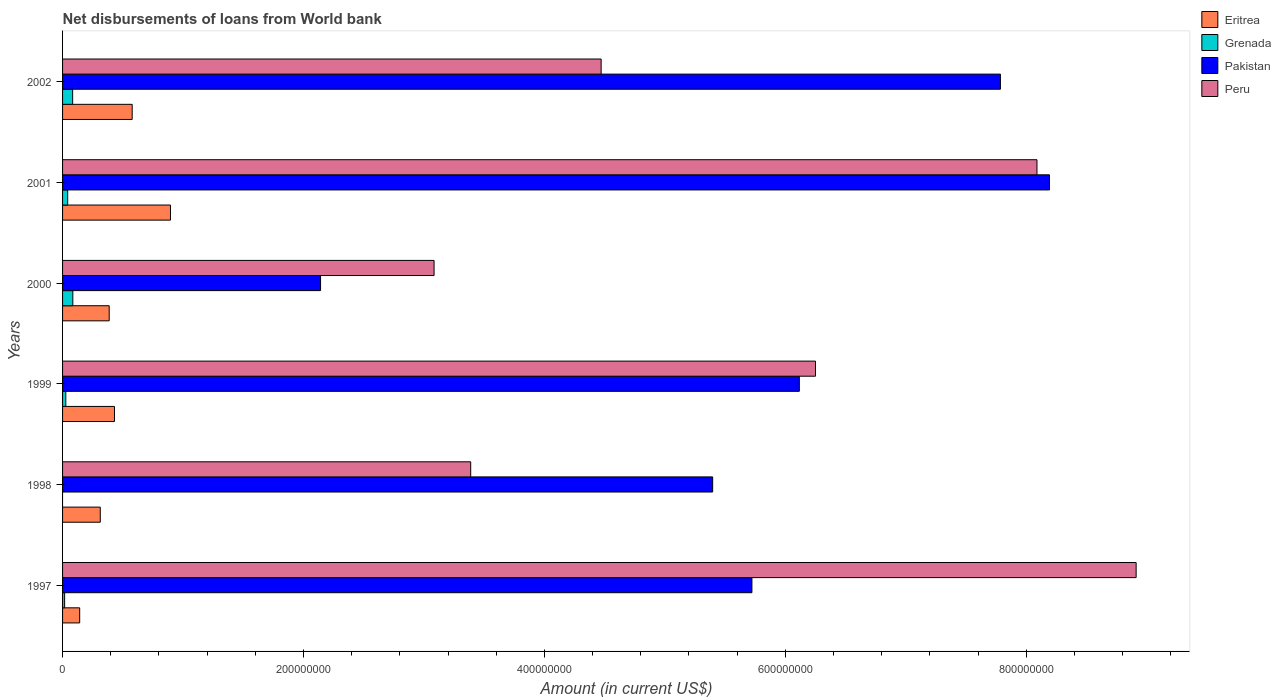How many different coloured bars are there?
Ensure brevity in your answer.  4. How many groups of bars are there?
Ensure brevity in your answer.  6. How many bars are there on the 3rd tick from the top?
Provide a short and direct response. 4. What is the amount of loan disbursed from World Bank in Grenada in 2002?
Your answer should be compact. 8.38e+06. Across all years, what is the maximum amount of loan disbursed from World Bank in Peru?
Provide a short and direct response. 8.91e+08. Across all years, what is the minimum amount of loan disbursed from World Bank in Pakistan?
Ensure brevity in your answer.  2.14e+08. In which year was the amount of loan disbursed from World Bank in Pakistan maximum?
Offer a very short reply. 2001. What is the total amount of loan disbursed from World Bank in Pakistan in the graph?
Your response must be concise. 3.54e+09. What is the difference between the amount of loan disbursed from World Bank in Grenada in 1997 and that in 1999?
Offer a terse response. -9.86e+05. What is the difference between the amount of loan disbursed from World Bank in Pakistan in 1998 and the amount of loan disbursed from World Bank in Grenada in 1997?
Provide a short and direct response. 5.38e+08. What is the average amount of loan disbursed from World Bank in Eritrea per year?
Your answer should be compact. 4.58e+07. In the year 1997, what is the difference between the amount of loan disbursed from World Bank in Pakistan and amount of loan disbursed from World Bank in Eritrea?
Keep it short and to the point. 5.58e+08. What is the ratio of the amount of loan disbursed from World Bank in Eritrea in 2000 to that in 2001?
Offer a very short reply. 0.43. Is the difference between the amount of loan disbursed from World Bank in Pakistan in 2000 and 2001 greater than the difference between the amount of loan disbursed from World Bank in Eritrea in 2000 and 2001?
Offer a terse response. No. What is the difference between the highest and the second highest amount of loan disbursed from World Bank in Peru?
Give a very brief answer. 8.23e+07. What is the difference between the highest and the lowest amount of loan disbursed from World Bank in Peru?
Your answer should be very brief. 5.83e+08. In how many years, is the amount of loan disbursed from World Bank in Grenada greater than the average amount of loan disbursed from World Bank in Grenada taken over all years?
Offer a terse response. 2. Is it the case that in every year, the sum of the amount of loan disbursed from World Bank in Peru and amount of loan disbursed from World Bank in Pakistan is greater than the sum of amount of loan disbursed from World Bank in Grenada and amount of loan disbursed from World Bank in Eritrea?
Keep it short and to the point. Yes. How many bars are there?
Ensure brevity in your answer.  23. How many years are there in the graph?
Ensure brevity in your answer.  6. Does the graph contain any zero values?
Your answer should be very brief. Yes. Does the graph contain grids?
Make the answer very short. No. Where does the legend appear in the graph?
Your answer should be very brief. Top right. How are the legend labels stacked?
Keep it short and to the point. Vertical. What is the title of the graph?
Ensure brevity in your answer.  Net disbursements of loans from World bank. What is the label or title of the X-axis?
Provide a short and direct response. Amount (in current US$). What is the label or title of the Y-axis?
Keep it short and to the point. Years. What is the Amount (in current US$) of Eritrea in 1997?
Ensure brevity in your answer.  1.42e+07. What is the Amount (in current US$) of Grenada in 1997?
Your answer should be very brief. 1.72e+06. What is the Amount (in current US$) of Pakistan in 1997?
Your response must be concise. 5.72e+08. What is the Amount (in current US$) of Peru in 1997?
Your answer should be compact. 8.91e+08. What is the Amount (in current US$) of Eritrea in 1998?
Ensure brevity in your answer.  3.13e+07. What is the Amount (in current US$) in Pakistan in 1998?
Provide a succinct answer. 5.40e+08. What is the Amount (in current US$) of Peru in 1998?
Keep it short and to the point. 3.39e+08. What is the Amount (in current US$) of Eritrea in 1999?
Make the answer very short. 4.31e+07. What is the Amount (in current US$) of Grenada in 1999?
Provide a short and direct response. 2.70e+06. What is the Amount (in current US$) in Pakistan in 1999?
Ensure brevity in your answer.  6.12e+08. What is the Amount (in current US$) in Peru in 1999?
Offer a very short reply. 6.25e+08. What is the Amount (in current US$) of Eritrea in 2000?
Your answer should be compact. 3.87e+07. What is the Amount (in current US$) of Grenada in 2000?
Offer a terse response. 8.52e+06. What is the Amount (in current US$) in Pakistan in 2000?
Offer a terse response. 2.14e+08. What is the Amount (in current US$) of Peru in 2000?
Provide a succinct answer. 3.08e+08. What is the Amount (in current US$) in Eritrea in 2001?
Your response must be concise. 8.96e+07. What is the Amount (in current US$) of Grenada in 2001?
Ensure brevity in your answer.  4.25e+06. What is the Amount (in current US$) in Pakistan in 2001?
Your answer should be compact. 8.19e+08. What is the Amount (in current US$) in Peru in 2001?
Your answer should be very brief. 8.09e+08. What is the Amount (in current US$) of Eritrea in 2002?
Your answer should be compact. 5.78e+07. What is the Amount (in current US$) in Grenada in 2002?
Your response must be concise. 8.38e+06. What is the Amount (in current US$) in Pakistan in 2002?
Give a very brief answer. 7.79e+08. What is the Amount (in current US$) in Peru in 2002?
Your answer should be compact. 4.47e+08. Across all years, what is the maximum Amount (in current US$) of Eritrea?
Your response must be concise. 8.96e+07. Across all years, what is the maximum Amount (in current US$) in Grenada?
Ensure brevity in your answer.  8.52e+06. Across all years, what is the maximum Amount (in current US$) in Pakistan?
Your answer should be very brief. 8.19e+08. Across all years, what is the maximum Amount (in current US$) of Peru?
Your answer should be very brief. 8.91e+08. Across all years, what is the minimum Amount (in current US$) of Eritrea?
Offer a terse response. 1.42e+07. Across all years, what is the minimum Amount (in current US$) of Grenada?
Your response must be concise. 0. Across all years, what is the minimum Amount (in current US$) in Pakistan?
Offer a very short reply. 2.14e+08. Across all years, what is the minimum Amount (in current US$) in Peru?
Offer a very short reply. 3.08e+08. What is the total Amount (in current US$) in Eritrea in the graph?
Your answer should be compact. 2.75e+08. What is the total Amount (in current US$) in Grenada in the graph?
Keep it short and to the point. 2.56e+07. What is the total Amount (in current US$) in Pakistan in the graph?
Offer a terse response. 3.54e+09. What is the total Amount (in current US$) in Peru in the graph?
Offer a very short reply. 3.42e+09. What is the difference between the Amount (in current US$) in Eritrea in 1997 and that in 1998?
Offer a terse response. -1.71e+07. What is the difference between the Amount (in current US$) of Pakistan in 1997 and that in 1998?
Your response must be concise. 3.26e+07. What is the difference between the Amount (in current US$) of Peru in 1997 and that in 1998?
Make the answer very short. 5.52e+08. What is the difference between the Amount (in current US$) in Eritrea in 1997 and that in 1999?
Your response must be concise. -2.89e+07. What is the difference between the Amount (in current US$) of Grenada in 1997 and that in 1999?
Offer a terse response. -9.86e+05. What is the difference between the Amount (in current US$) of Pakistan in 1997 and that in 1999?
Keep it short and to the point. -3.94e+07. What is the difference between the Amount (in current US$) of Peru in 1997 and that in 1999?
Give a very brief answer. 2.66e+08. What is the difference between the Amount (in current US$) of Eritrea in 1997 and that in 2000?
Give a very brief answer. -2.45e+07. What is the difference between the Amount (in current US$) of Grenada in 1997 and that in 2000?
Your answer should be compact. -6.80e+06. What is the difference between the Amount (in current US$) of Pakistan in 1997 and that in 2000?
Offer a terse response. 3.58e+08. What is the difference between the Amount (in current US$) of Peru in 1997 and that in 2000?
Keep it short and to the point. 5.83e+08. What is the difference between the Amount (in current US$) of Eritrea in 1997 and that in 2001?
Offer a very short reply. -7.54e+07. What is the difference between the Amount (in current US$) of Grenada in 1997 and that in 2001?
Provide a succinct answer. -2.54e+06. What is the difference between the Amount (in current US$) in Pakistan in 1997 and that in 2001?
Provide a succinct answer. -2.47e+08. What is the difference between the Amount (in current US$) of Peru in 1997 and that in 2001?
Offer a terse response. 8.23e+07. What is the difference between the Amount (in current US$) of Eritrea in 1997 and that in 2002?
Provide a succinct answer. -4.36e+07. What is the difference between the Amount (in current US$) of Grenada in 1997 and that in 2002?
Offer a very short reply. -6.66e+06. What is the difference between the Amount (in current US$) of Pakistan in 1997 and that in 2002?
Give a very brief answer. -2.06e+08. What is the difference between the Amount (in current US$) of Peru in 1997 and that in 2002?
Provide a short and direct response. 4.44e+08. What is the difference between the Amount (in current US$) of Eritrea in 1998 and that in 1999?
Provide a succinct answer. -1.18e+07. What is the difference between the Amount (in current US$) in Pakistan in 1998 and that in 1999?
Your answer should be compact. -7.19e+07. What is the difference between the Amount (in current US$) of Peru in 1998 and that in 1999?
Your answer should be compact. -2.86e+08. What is the difference between the Amount (in current US$) in Eritrea in 1998 and that in 2000?
Your answer should be very brief. -7.42e+06. What is the difference between the Amount (in current US$) of Pakistan in 1998 and that in 2000?
Make the answer very short. 3.26e+08. What is the difference between the Amount (in current US$) in Peru in 1998 and that in 2000?
Provide a short and direct response. 3.04e+07. What is the difference between the Amount (in current US$) in Eritrea in 1998 and that in 2001?
Your answer should be very brief. -5.83e+07. What is the difference between the Amount (in current US$) in Pakistan in 1998 and that in 2001?
Make the answer very short. -2.80e+08. What is the difference between the Amount (in current US$) in Peru in 1998 and that in 2001?
Provide a succinct answer. -4.70e+08. What is the difference between the Amount (in current US$) in Eritrea in 1998 and that in 2002?
Provide a succinct answer. -2.65e+07. What is the difference between the Amount (in current US$) in Pakistan in 1998 and that in 2002?
Make the answer very short. -2.39e+08. What is the difference between the Amount (in current US$) of Peru in 1998 and that in 2002?
Your response must be concise. -1.08e+08. What is the difference between the Amount (in current US$) of Eritrea in 1999 and that in 2000?
Provide a succinct answer. 4.38e+06. What is the difference between the Amount (in current US$) in Grenada in 1999 and that in 2000?
Give a very brief answer. -5.82e+06. What is the difference between the Amount (in current US$) in Pakistan in 1999 and that in 2000?
Keep it short and to the point. 3.97e+08. What is the difference between the Amount (in current US$) in Peru in 1999 and that in 2000?
Give a very brief answer. 3.17e+08. What is the difference between the Amount (in current US$) of Eritrea in 1999 and that in 2001?
Your answer should be very brief. -4.65e+07. What is the difference between the Amount (in current US$) in Grenada in 1999 and that in 2001?
Ensure brevity in your answer.  -1.55e+06. What is the difference between the Amount (in current US$) of Pakistan in 1999 and that in 2001?
Offer a terse response. -2.08e+08. What is the difference between the Amount (in current US$) of Peru in 1999 and that in 2001?
Offer a terse response. -1.84e+08. What is the difference between the Amount (in current US$) of Eritrea in 1999 and that in 2002?
Offer a terse response. -1.47e+07. What is the difference between the Amount (in current US$) in Grenada in 1999 and that in 2002?
Your answer should be very brief. -5.67e+06. What is the difference between the Amount (in current US$) in Pakistan in 1999 and that in 2002?
Make the answer very short. -1.67e+08. What is the difference between the Amount (in current US$) of Peru in 1999 and that in 2002?
Provide a short and direct response. 1.78e+08. What is the difference between the Amount (in current US$) in Eritrea in 2000 and that in 2001?
Provide a short and direct response. -5.09e+07. What is the difference between the Amount (in current US$) in Grenada in 2000 and that in 2001?
Ensure brevity in your answer.  4.27e+06. What is the difference between the Amount (in current US$) in Pakistan in 2000 and that in 2001?
Give a very brief answer. -6.05e+08. What is the difference between the Amount (in current US$) in Peru in 2000 and that in 2001?
Your response must be concise. -5.00e+08. What is the difference between the Amount (in current US$) in Eritrea in 2000 and that in 2002?
Provide a short and direct response. -1.91e+07. What is the difference between the Amount (in current US$) of Grenada in 2000 and that in 2002?
Provide a succinct answer. 1.44e+05. What is the difference between the Amount (in current US$) of Pakistan in 2000 and that in 2002?
Keep it short and to the point. -5.64e+08. What is the difference between the Amount (in current US$) of Peru in 2000 and that in 2002?
Make the answer very short. -1.39e+08. What is the difference between the Amount (in current US$) of Eritrea in 2001 and that in 2002?
Provide a short and direct response. 3.18e+07. What is the difference between the Amount (in current US$) of Grenada in 2001 and that in 2002?
Ensure brevity in your answer.  -4.12e+06. What is the difference between the Amount (in current US$) in Pakistan in 2001 and that in 2002?
Your response must be concise. 4.07e+07. What is the difference between the Amount (in current US$) of Peru in 2001 and that in 2002?
Your answer should be very brief. 3.62e+08. What is the difference between the Amount (in current US$) in Eritrea in 1997 and the Amount (in current US$) in Pakistan in 1998?
Your response must be concise. -5.25e+08. What is the difference between the Amount (in current US$) in Eritrea in 1997 and the Amount (in current US$) in Peru in 1998?
Keep it short and to the point. -3.25e+08. What is the difference between the Amount (in current US$) of Grenada in 1997 and the Amount (in current US$) of Pakistan in 1998?
Ensure brevity in your answer.  -5.38e+08. What is the difference between the Amount (in current US$) in Grenada in 1997 and the Amount (in current US$) in Peru in 1998?
Provide a short and direct response. -3.37e+08. What is the difference between the Amount (in current US$) of Pakistan in 1997 and the Amount (in current US$) of Peru in 1998?
Your response must be concise. 2.33e+08. What is the difference between the Amount (in current US$) of Eritrea in 1997 and the Amount (in current US$) of Grenada in 1999?
Offer a very short reply. 1.15e+07. What is the difference between the Amount (in current US$) in Eritrea in 1997 and the Amount (in current US$) in Pakistan in 1999?
Offer a very short reply. -5.97e+08. What is the difference between the Amount (in current US$) of Eritrea in 1997 and the Amount (in current US$) of Peru in 1999?
Ensure brevity in your answer.  -6.11e+08. What is the difference between the Amount (in current US$) in Grenada in 1997 and the Amount (in current US$) in Pakistan in 1999?
Your response must be concise. -6.10e+08. What is the difference between the Amount (in current US$) of Grenada in 1997 and the Amount (in current US$) of Peru in 1999?
Your answer should be very brief. -6.23e+08. What is the difference between the Amount (in current US$) in Pakistan in 1997 and the Amount (in current US$) in Peru in 1999?
Offer a terse response. -5.28e+07. What is the difference between the Amount (in current US$) in Eritrea in 1997 and the Amount (in current US$) in Grenada in 2000?
Keep it short and to the point. 5.69e+06. What is the difference between the Amount (in current US$) in Eritrea in 1997 and the Amount (in current US$) in Pakistan in 2000?
Your answer should be very brief. -2.00e+08. What is the difference between the Amount (in current US$) of Eritrea in 1997 and the Amount (in current US$) of Peru in 2000?
Give a very brief answer. -2.94e+08. What is the difference between the Amount (in current US$) in Grenada in 1997 and the Amount (in current US$) in Pakistan in 2000?
Ensure brevity in your answer.  -2.12e+08. What is the difference between the Amount (in current US$) of Grenada in 1997 and the Amount (in current US$) of Peru in 2000?
Offer a very short reply. -3.07e+08. What is the difference between the Amount (in current US$) of Pakistan in 1997 and the Amount (in current US$) of Peru in 2000?
Your response must be concise. 2.64e+08. What is the difference between the Amount (in current US$) of Eritrea in 1997 and the Amount (in current US$) of Grenada in 2001?
Your response must be concise. 9.96e+06. What is the difference between the Amount (in current US$) of Eritrea in 1997 and the Amount (in current US$) of Pakistan in 2001?
Your response must be concise. -8.05e+08. What is the difference between the Amount (in current US$) of Eritrea in 1997 and the Amount (in current US$) of Peru in 2001?
Your response must be concise. -7.95e+08. What is the difference between the Amount (in current US$) in Grenada in 1997 and the Amount (in current US$) in Pakistan in 2001?
Your response must be concise. -8.18e+08. What is the difference between the Amount (in current US$) of Grenada in 1997 and the Amount (in current US$) of Peru in 2001?
Offer a very short reply. -8.07e+08. What is the difference between the Amount (in current US$) of Pakistan in 1997 and the Amount (in current US$) of Peru in 2001?
Offer a terse response. -2.37e+08. What is the difference between the Amount (in current US$) in Eritrea in 1997 and the Amount (in current US$) in Grenada in 2002?
Ensure brevity in your answer.  5.83e+06. What is the difference between the Amount (in current US$) in Eritrea in 1997 and the Amount (in current US$) in Pakistan in 2002?
Keep it short and to the point. -7.64e+08. What is the difference between the Amount (in current US$) of Eritrea in 1997 and the Amount (in current US$) of Peru in 2002?
Provide a succinct answer. -4.33e+08. What is the difference between the Amount (in current US$) in Grenada in 1997 and the Amount (in current US$) in Pakistan in 2002?
Provide a short and direct response. -7.77e+08. What is the difference between the Amount (in current US$) in Grenada in 1997 and the Amount (in current US$) in Peru in 2002?
Give a very brief answer. -4.45e+08. What is the difference between the Amount (in current US$) of Pakistan in 1997 and the Amount (in current US$) of Peru in 2002?
Make the answer very short. 1.25e+08. What is the difference between the Amount (in current US$) in Eritrea in 1998 and the Amount (in current US$) in Grenada in 1999?
Ensure brevity in your answer.  2.86e+07. What is the difference between the Amount (in current US$) in Eritrea in 1998 and the Amount (in current US$) in Pakistan in 1999?
Ensure brevity in your answer.  -5.80e+08. What is the difference between the Amount (in current US$) of Eritrea in 1998 and the Amount (in current US$) of Peru in 1999?
Your answer should be compact. -5.94e+08. What is the difference between the Amount (in current US$) in Pakistan in 1998 and the Amount (in current US$) in Peru in 1999?
Give a very brief answer. -8.54e+07. What is the difference between the Amount (in current US$) in Eritrea in 1998 and the Amount (in current US$) in Grenada in 2000?
Offer a terse response. 2.28e+07. What is the difference between the Amount (in current US$) in Eritrea in 1998 and the Amount (in current US$) in Pakistan in 2000?
Your response must be concise. -1.83e+08. What is the difference between the Amount (in current US$) in Eritrea in 1998 and the Amount (in current US$) in Peru in 2000?
Offer a very short reply. -2.77e+08. What is the difference between the Amount (in current US$) in Pakistan in 1998 and the Amount (in current US$) in Peru in 2000?
Provide a succinct answer. 2.31e+08. What is the difference between the Amount (in current US$) of Eritrea in 1998 and the Amount (in current US$) of Grenada in 2001?
Provide a succinct answer. 2.71e+07. What is the difference between the Amount (in current US$) of Eritrea in 1998 and the Amount (in current US$) of Pakistan in 2001?
Provide a succinct answer. -7.88e+08. What is the difference between the Amount (in current US$) of Eritrea in 1998 and the Amount (in current US$) of Peru in 2001?
Provide a succinct answer. -7.78e+08. What is the difference between the Amount (in current US$) of Pakistan in 1998 and the Amount (in current US$) of Peru in 2001?
Offer a very short reply. -2.69e+08. What is the difference between the Amount (in current US$) of Eritrea in 1998 and the Amount (in current US$) of Grenada in 2002?
Make the answer very short. 2.29e+07. What is the difference between the Amount (in current US$) in Eritrea in 1998 and the Amount (in current US$) in Pakistan in 2002?
Provide a succinct answer. -7.47e+08. What is the difference between the Amount (in current US$) of Eritrea in 1998 and the Amount (in current US$) of Peru in 2002?
Your answer should be compact. -4.16e+08. What is the difference between the Amount (in current US$) of Pakistan in 1998 and the Amount (in current US$) of Peru in 2002?
Give a very brief answer. 9.26e+07. What is the difference between the Amount (in current US$) in Eritrea in 1999 and the Amount (in current US$) in Grenada in 2000?
Ensure brevity in your answer.  3.46e+07. What is the difference between the Amount (in current US$) of Eritrea in 1999 and the Amount (in current US$) of Pakistan in 2000?
Your answer should be very brief. -1.71e+08. What is the difference between the Amount (in current US$) in Eritrea in 1999 and the Amount (in current US$) in Peru in 2000?
Provide a succinct answer. -2.65e+08. What is the difference between the Amount (in current US$) of Grenada in 1999 and the Amount (in current US$) of Pakistan in 2000?
Offer a very short reply. -2.11e+08. What is the difference between the Amount (in current US$) of Grenada in 1999 and the Amount (in current US$) of Peru in 2000?
Give a very brief answer. -3.06e+08. What is the difference between the Amount (in current US$) of Pakistan in 1999 and the Amount (in current US$) of Peru in 2000?
Your answer should be very brief. 3.03e+08. What is the difference between the Amount (in current US$) of Eritrea in 1999 and the Amount (in current US$) of Grenada in 2001?
Offer a terse response. 3.89e+07. What is the difference between the Amount (in current US$) of Eritrea in 1999 and the Amount (in current US$) of Pakistan in 2001?
Give a very brief answer. -7.76e+08. What is the difference between the Amount (in current US$) of Eritrea in 1999 and the Amount (in current US$) of Peru in 2001?
Your response must be concise. -7.66e+08. What is the difference between the Amount (in current US$) in Grenada in 1999 and the Amount (in current US$) in Pakistan in 2001?
Ensure brevity in your answer.  -8.17e+08. What is the difference between the Amount (in current US$) in Grenada in 1999 and the Amount (in current US$) in Peru in 2001?
Provide a short and direct response. -8.06e+08. What is the difference between the Amount (in current US$) in Pakistan in 1999 and the Amount (in current US$) in Peru in 2001?
Offer a very short reply. -1.97e+08. What is the difference between the Amount (in current US$) in Eritrea in 1999 and the Amount (in current US$) in Grenada in 2002?
Ensure brevity in your answer.  3.47e+07. What is the difference between the Amount (in current US$) of Eritrea in 1999 and the Amount (in current US$) of Pakistan in 2002?
Offer a very short reply. -7.35e+08. What is the difference between the Amount (in current US$) of Eritrea in 1999 and the Amount (in current US$) of Peru in 2002?
Provide a succinct answer. -4.04e+08. What is the difference between the Amount (in current US$) of Grenada in 1999 and the Amount (in current US$) of Pakistan in 2002?
Your answer should be very brief. -7.76e+08. What is the difference between the Amount (in current US$) of Grenada in 1999 and the Amount (in current US$) of Peru in 2002?
Your answer should be compact. -4.44e+08. What is the difference between the Amount (in current US$) of Pakistan in 1999 and the Amount (in current US$) of Peru in 2002?
Provide a succinct answer. 1.65e+08. What is the difference between the Amount (in current US$) of Eritrea in 2000 and the Amount (in current US$) of Grenada in 2001?
Your response must be concise. 3.45e+07. What is the difference between the Amount (in current US$) of Eritrea in 2000 and the Amount (in current US$) of Pakistan in 2001?
Make the answer very short. -7.81e+08. What is the difference between the Amount (in current US$) in Eritrea in 2000 and the Amount (in current US$) in Peru in 2001?
Your response must be concise. -7.70e+08. What is the difference between the Amount (in current US$) in Grenada in 2000 and the Amount (in current US$) in Pakistan in 2001?
Keep it short and to the point. -8.11e+08. What is the difference between the Amount (in current US$) in Grenada in 2000 and the Amount (in current US$) in Peru in 2001?
Make the answer very short. -8.00e+08. What is the difference between the Amount (in current US$) of Pakistan in 2000 and the Amount (in current US$) of Peru in 2001?
Your answer should be compact. -5.95e+08. What is the difference between the Amount (in current US$) of Eritrea in 2000 and the Amount (in current US$) of Grenada in 2002?
Provide a succinct answer. 3.03e+07. What is the difference between the Amount (in current US$) in Eritrea in 2000 and the Amount (in current US$) in Pakistan in 2002?
Offer a very short reply. -7.40e+08. What is the difference between the Amount (in current US$) of Eritrea in 2000 and the Amount (in current US$) of Peru in 2002?
Offer a terse response. -4.08e+08. What is the difference between the Amount (in current US$) in Grenada in 2000 and the Amount (in current US$) in Pakistan in 2002?
Give a very brief answer. -7.70e+08. What is the difference between the Amount (in current US$) in Grenada in 2000 and the Amount (in current US$) in Peru in 2002?
Your response must be concise. -4.39e+08. What is the difference between the Amount (in current US$) of Pakistan in 2000 and the Amount (in current US$) of Peru in 2002?
Give a very brief answer. -2.33e+08. What is the difference between the Amount (in current US$) in Eritrea in 2001 and the Amount (in current US$) in Grenada in 2002?
Ensure brevity in your answer.  8.12e+07. What is the difference between the Amount (in current US$) of Eritrea in 2001 and the Amount (in current US$) of Pakistan in 2002?
Keep it short and to the point. -6.89e+08. What is the difference between the Amount (in current US$) in Eritrea in 2001 and the Amount (in current US$) in Peru in 2002?
Your answer should be compact. -3.58e+08. What is the difference between the Amount (in current US$) in Grenada in 2001 and the Amount (in current US$) in Pakistan in 2002?
Give a very brief answer. -7.74e+08. What is the difference between the Amount (in current US$) in Grenada in 2001 and the Amount (in current US$) in Peru in 2002?
Offer a very short reply. -4.43e+08. What is the difference between the Amount (in current US$) in Pakistan in 2001 and the Amount (in current US$) in Peru in 2002?
Provide a short and direct response. 3.72e+08. What is the average Amount (in current US$) in Eritrea per year?
Offer a terse response. 4.58e+07. What is the average Amount (in current US$) of Grenada per year?
Keep it short and to the point. 4.26e+06. What is the average Amount (in current US$) in Pakistan per year?
Keep it short and to the point. 5.89e+08. What is the average Amount (in current US$) in Peru per year?
Your answer should be very brief. 5.70e+08. In the year 1997, what is the difference between the Amount (in current US$) of Eritrea and Amount (in current US$) of Grenada?
Offer a terse response. 1.25e+07. In the year 1997, what is the difference between the Amount (in current US$) in Eritrea and Amount (in current US$) in Pakistan?
Provide a short and direct response. -5.58e+08. In the year 1997, what is the difference between the Amount (in current US$) in Eritrea and Amount (in current US$) in Peru?
Provide a succinct answer. -8.77e+08. In the year 1997, what is the difference between the Amount (in current US$) of Grenada and Amount (in current US$) of Pakistan?
Your answer should be compact. -5.71e+08. In the year 1997, what is the difference between the Amount (in current US$) of Grenada and Amount (in current US$) of Peru?
Your response must be concise. -8.90e+08. In the year 1997, what is the difference between the Amount (in current US$) of Pakistan and Amount (in current US$) of Peru?
Provide a succinct answer. -3.19e+08. In the year 1998, what is the difference between the Amount (in current US$) in Eritrea and Amount (in current US$) in Pakistan?
Provide a short and direct response. -5.08e+08. In the year 1998, what is the difference between the Amount (in current US$) of Eritrea and Amount (in current US$) of Peru?
Offer a very short reply. -3.08e+08. In the year 1998, what is the difference between the Amount (in current US$) of Pakistan and Amount (in current US$) of Peru?
Ensure brevity in your answer.  2.01e+08. In the year 1999, what is the difference between the Amount (in current US$) of Eritrea and Amount (in current US$) of Grenada?
Ensure brevity in your answer.  4.04e+07. In the year 1999, what is the difference between the Amount (in current US$) in Eritrea and Amount (in current US$) in Pakistan?
Your answer should be compact. -5.69e+08. In the year 1999, what is the difference between the Amount (in current US$) in Eritrea and Amount (in current US$) in Peru?
Your answer should be very brief. -5.82e+08. In the year 1999, what is the difference between the Amount (in current US$) of Grenada and Amount (in current US$) of Pakistan?
Your response must be concise. -6.09e+08. In the year 1999, what is the difference between the Amount (in current US$) in Grenada and Amount (in current US$) in Peru?
Offer a very short reply. -6.22e+08. In the year 1999, what is the difference between the Amount (in current US$) in Pakistan and Amount (in current US$) in Peru?
Offer a terse response. -1.34e+07. In the year 2000, what is the difference between the Amount (in current US$) of Eritrea and Amount (in current US$) of Grenada?
Give a very brief answer. 3.02e+07. In the year 2000, what is the difference between the Amount (in current US$) of Eritrea and Amount (in current US$) of Pakistan?
Offer a terse response. -1.75e+08. In the year 2000, what is the difference between the Amount (in current US$) of Eritrea and Amount (in current US$) of Peru?
Offer a terse response. -2.70e+08. In the year 2000, what is the difference between the Amount (in current US$) in Grenada and Amount (in current US$) in Pakistan?
Make the answer very short. -2.06e+08. In the year 2000, what is the difference between the Amount (in current US$) of Grenada and Amount (in current US$) of Peru?
Give a very brief answer. -3.00e+08. In the year 2000, what is the difference between the Amount (in current US$) in Pakistan and Amount (in current US$) in Peru?
Give a very brief answer. -9.42e+07. In the year 2001, what is the difference between the Amount (in current US$) of Eritrea and Amount (in current US$) of Grenada?
Provide a succinct answer. 8.53e+07. In the year 2001, what is the difference between the Amount (in current US$) in Eritrea and Amount (in current US$) in Pakistan?
Give a very brief answer. -7.30e+08. In the year 2001, what is the difference between the Amount (in current US$) in Eritrea and Amount (in current US$) in Peru?
Your answer should be compact. -7.19e+08. In the year 2001, what is the difference between the Amount (in current US$) in Grenada and Amount (in current US$) in Pakistan?
Offer a very short reply. -8.15e+08. In the year 2001, what is the difference between the Amount (in current US$) in Grenada and Amount (in current US$) in Peru?
Offer a very short reply. -8.05e+08. In the year 2001, what is the difference between the Amount (in current US$) in Pakistan and Amount (in current US$) in Peru?
Provide a succinct answer. 1.04e+07. In the year 2002, what is the difference between the Amount (in current US$) in Eritrea and Amount (in current US$) in Grenada?
Your response must be concise. 4.94e+07. In the year 2002, what is the difference between the Amount (in current US$) in Eritrea and Amount (in current US$) in Pakistan?
Make the answer very short. -7.21e+08. In the year 2002, what is the difference between the Amount (in current US$) of Eritrea and Amount (in current US$) of Peru?
Ensure brevity in your answer.  -3.89e+08. In the year 2002, what is the difference between the Amount (in current US$) in Grenada and Amount (in current US$) in Pakistan?
Your answer should be very brief. -7.70e+08. In the year 2002, what is the difference between the Amount (in current US$) in Grenada and Amount (in current US$) in Peru?
Your response must be concise. -4.39e+08. In the year 2002, what is the difference between the Amount (in current US$) in Pakistan and Amount (in current US$) in Peru?
Offer a very short reply. 3.31e+08. What is the ratio of the Amount (in current US$) in Eritrea in 1997 to that in 1998?
Offer a terse response. 0.45. What is the ratio of the Amount (in current US$) of Pakistan in 1997 to that in 1998?
Offer a terse response. 1.06. What is the ratio of the Amount (in current US$) in Peru in 1997 to that in 1998?
Your answer should be very brief. 2.63. What is the ratio of the Amount (in current US$) of Eritrea in 1997 to that in 1999?
Offer a very short reply. 0.33. What is the ratio of the Amount (in current US$) in Grenada in 1997 to that in 1999?
Your response must be concise. 0.64. What is the ratio of the Amount (in current US$) of Pakistan in 1997 to that in 1999?
Offer a terse response. 0.94. What is the ratio of the Amount (in current US$) in Peru in 1997 to that in 1999?
Provide a short and direct response. 1.43. What is the ratio of the Amount (in current US$) of Eritrea in 1997 to that in 2000?
Offer a terse response. 0.37. What is the ratio of the Amount (in current US$) in Grenada in 1997 to that in 2000?
Provide a short and direct response. 0.2. What is the ratio of the Amount (in current US$) in Pakistan in 1997 to that in 2000?
Your answer should be very brief. 2.67. What is the ratio of the Amount (in current US$) in Peru in 1997 to that in 2000?
Provide a short and direct response. 2.89. What is the ratio of the Amount (in current US$) in Eritrea in 1997 to that in 2001?
Offer a terse response. 0.16. What is the ratio of the Amount (in current US$) in Grenada in 1997 to that in 2001?
Ensure brevity in your answer.  0.4. What is the ratio of the Amount (in current US$) in Pakistan in 1997 to that in 2001?
Provide a succinct answer. 0.7. What is the ratio of the Amount (in current US$) in Peru in 1997 to that in 2001?
Your answer should be very brief. 1.1. What is the ratio of the Amount (in current US$) in Eritrea in 1997 to that in 2002?
Offer a terse response. 0.25. What is the ratio of the Amount (in current US$) of Grenada in 1997 to that in 2002?
Offer a very short reply. 0.2. What is the ratio of the Amount (in current US$) in Pakistan in 1997 to that in 2002?
Your answer should be very brief. 0.73. What is the ratio of the Amount (in current US$) in Peru in 1997 to that in 2002?
Provide a succinct answer. 1.99. What is the ratio of the Amount (in current US$) of Eritrea in 1998 to that in 1999?
Ensure brevity in your answer.  0.73. What is the ratio of the Amount (in current US$) in Pakistan in 1998 to that in 1999?
Provide a succinct answer. 0.88. What is the ratio of the Amount (in current US$) in Peru in 1998 to that in 1999?
Provide a short and direct response. 0.54. What is the ratio of the Amount (in current US$) in Eritrea in 1998 to that in 2000?
Ensure brevity in your answer.  0.81. What is the ratio of the Amount (in current US$) in Pakistan in 1998 to that in 2000?
Your answer should be very brief. 2.52. What is the ratio of the Amount (in current US$) of Peru in 1998 to that in 2000?
Your answer should be very brief. 1.1. What is the ratio of the Amount (in current US$) of Eritrea in 1998 to that in 2001?
Your answer should be compact. 0.35. What is the ratio of the Amount (in current US$) in Pakistan in 1998 to that in 2001?
Keep it short and to the point. 0.66. What is the ratio of the Amount (in current US$) in Peru in 1998 to that in 2001?
Your response must be concise. 0.42. What is the ratio of the Amount (in current US$) of Eritrea in 1998 to that in 2002?
Ensure brevity in your answer.  0.54. What is the ratio of the Amount (in current US$) in Pakistan in 1998 to that in 2002?
Your answer should be compact. 0.69. What is the ratio of the Amount (in current US$) of Peru in 1998 to that in 2002?
Make the answer very short. 0.76. What is the ratio of the Amount (in current US$) of Eritrea in 1999 to that in 2000?
Give a very brief answer. 1.11. What is the ratio of the Amount (in current US$) in Grenada in 1999 to that in 2000?
Ensure brevity in your answer.  0.32. What is the ratio of the Amount (in current US$) in Pakistan in 1999 to that in 2000?
Offer a very short reply. 2.86. What is the ratio of the Amount (in current US$) of Peru in 1999 to that in 2000?
Make the answer very short. 2.03. What is the ratio of the Amount (in current US$) of Eritrea in 1999 to that in 2001?
Provide a succinct answer. 0.48. What is the ratio of the Amount (in current US$) in Grenada in 1999 to that in 2001?
Provide a short and direct response. 0.64. What is the ratio of the Amount (in current US$) in Pakistan in 1999 to that in 2001?
Offer a very short reply. 0.75. What is the ratio of the Amount (in current US$) in Peru in 1999 to that in 2001?
Offer a very short reply. 0.77. What is the ratio of the Amount (in current US$) in Eritrea in 1999 to that in 2002?
Offer a very short reply. 0.75. What is the ratio of the Amount (in current US$) of Grenada in 1999 to that in 2002?
Ensure brevity in your answer.  0.32. What is the ratio of the Amount (in current US$) of Pakistan in 1999 to that in 2002?
Your answer should be very brief. 0.79. What is the ratio of the Amount (in current US$) in Peru in 1999 to that in 2002?
Give a very brief answer. 1.4. What is the ratio of the Amount (in current US$) of Eritrea in 2000 to that in 2001?
Provide a short and direct response. 0.43. What is the ratio of the Amount (in current US$) in Grenada in 2000 to that in 2001?
Your answer should be very brief. 2. What is the ratio of the Amount (in current US$) of Pakistan in 2000 to that in 2001?
Provide a short and direct response. 0.26. What is the ratio of the Amount (in current US$) in Peru in 2000 to that in 2001?
Provide a succinct answer. 0.38. What is the ratio of the Amount (in current US$) in Eritrea in 2000 to that in 2002?
Give a very brief answer. 0.67. What is the ratio of the Amount (in current US$) of Grenada in 2000 to that in 2002?
Ensure brevity in your answer.  1.02. What is the ratio of the Amount (in current US$) of Pakistan in 2000 to that in 2002?
Ensure brevity in your answer.  0.28. What is the ratio of the Amount (in current US$) in Peru in 2000 to that in 2002?
Your answer should be very brief. 0.69. What is the ratio of the Amount (in current US$) of Eritrea in 2001 to that in 2002?
Your answer should be compact. 1.55. What is the ratio of the Amount (in current US$) in Grenada in 2001 to that in 2002?
Your answer should be very brief. 0.51. What is the ratio of the Amount (in current US$) of Pakistan in 2001 to that in 2002?
Make the answer very short. 1.05. What is the ratio of the Amount (in current US$) of Peru in 2001 to that in 2002?
Make the answer very short. 1.81. What is the difference between the highest and the second highest Amount (in current US$) in Eritrea?
Your answer should be compact. 3.18e+07. What is the difference between the highest and the second highest Amount (in current US$) in Grenada?
Offer a terse response. 1.44e+05. What is the difference between the highest and the second highest Amount (in current US$) in Pakistan?
Provide a succinct answer. 4.07e+07. What is the difference between the highest and the second highest Amount (in current US$) in Peru?
Provide a succinct answer. 8.23e+07. What is the difference between the highest and the lowest Amount (in current US$) in Eritrea?
Keep it short and to the point. 7.54e+07. What is the difference between the highest and the lowest Amount (in current US$) of Grenada?
Offer a very short reply. 8.52e+06. What is the difference between the highest and the lowest Amount (in current US$) of Pakistan?
Your answer should be compact. 6.05e+08. What is the difference between the highest and the lowest Amount (in current US$) in Peru?
Your answer should be very brief. 5.83e+08. 